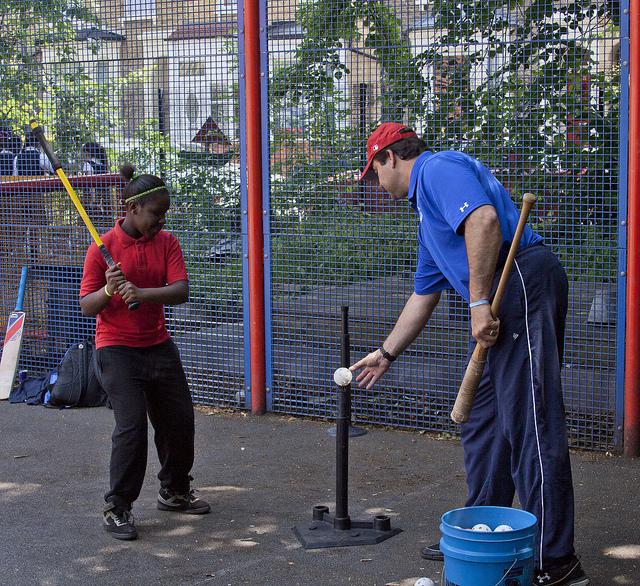What sport are they playing?
Keep it brief. Baseball. Is the man wearing a wedding band?
Short answer required. Yes. Is the girl older than the man?
Write a very short answer. No. 